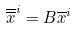<formula> <loc_0><loc_0><loc_500><loc_500>\overline { \overline { x } } ^ { i } = B \overline { x } ^ { i }</formula> 